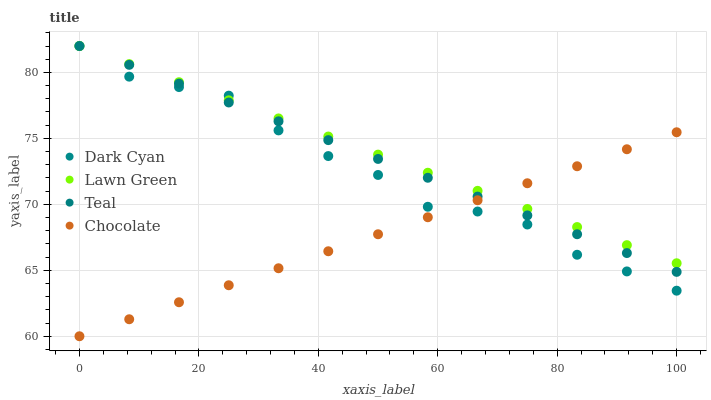Does Chocolate have the minimum area under the curve?
Answer yes or no. Yes. Does Lawn Green have the maximum area under the curve?
Answer yes or no. Yes. Does Teal have the minimum area under the curve?
Answer yes or no. No. Does Teal have the maximum area under the curve?
Answer yes or no. No. Is Lawn Green the smoothest?
Answer yes or no. Yes. Is Dark Cyan the roughest?
Answer yes or no. Yes. Is Teal the smoothest?
Answer yes or no. No. Is Teal the roughest?
Answer yes or no. No. Does Chocolate have the lowest value?
Answer yes or no. Yes. Does Teal have the lowest value?
Answer yes or no. No. Does Teal have the highest value?
Answer yes or no. Yes. Does Chocolate have the highest value?
Answer yes or no. No. Does Chocolate intersect Lawn Green?
Answer yes or no. Yes. Is Chocolate less than Lawn Green?
Answer yes or no. No. Is Chocolate greater than Lawn Green?
Answer yes or no. No. 